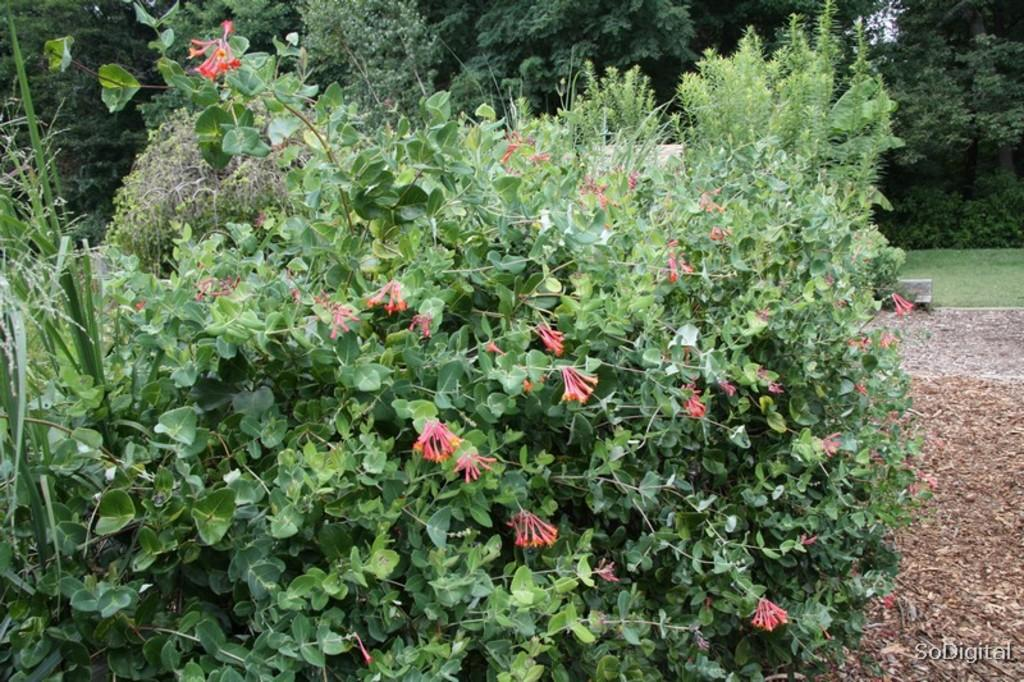What type of plants can be seen in the image? There are plants with flowers in the image. What type of vegetation is visible at ground level? There is grass visible in the image. What can be seen in the distance in the image? There are trees in the background of the image. How many rings are visible on the tree trunks in the image? There are no tree trunks visible in the image, only trees in the background. What is the height of the grass in the image? The height of the grass cannot be determined from the image alone. 